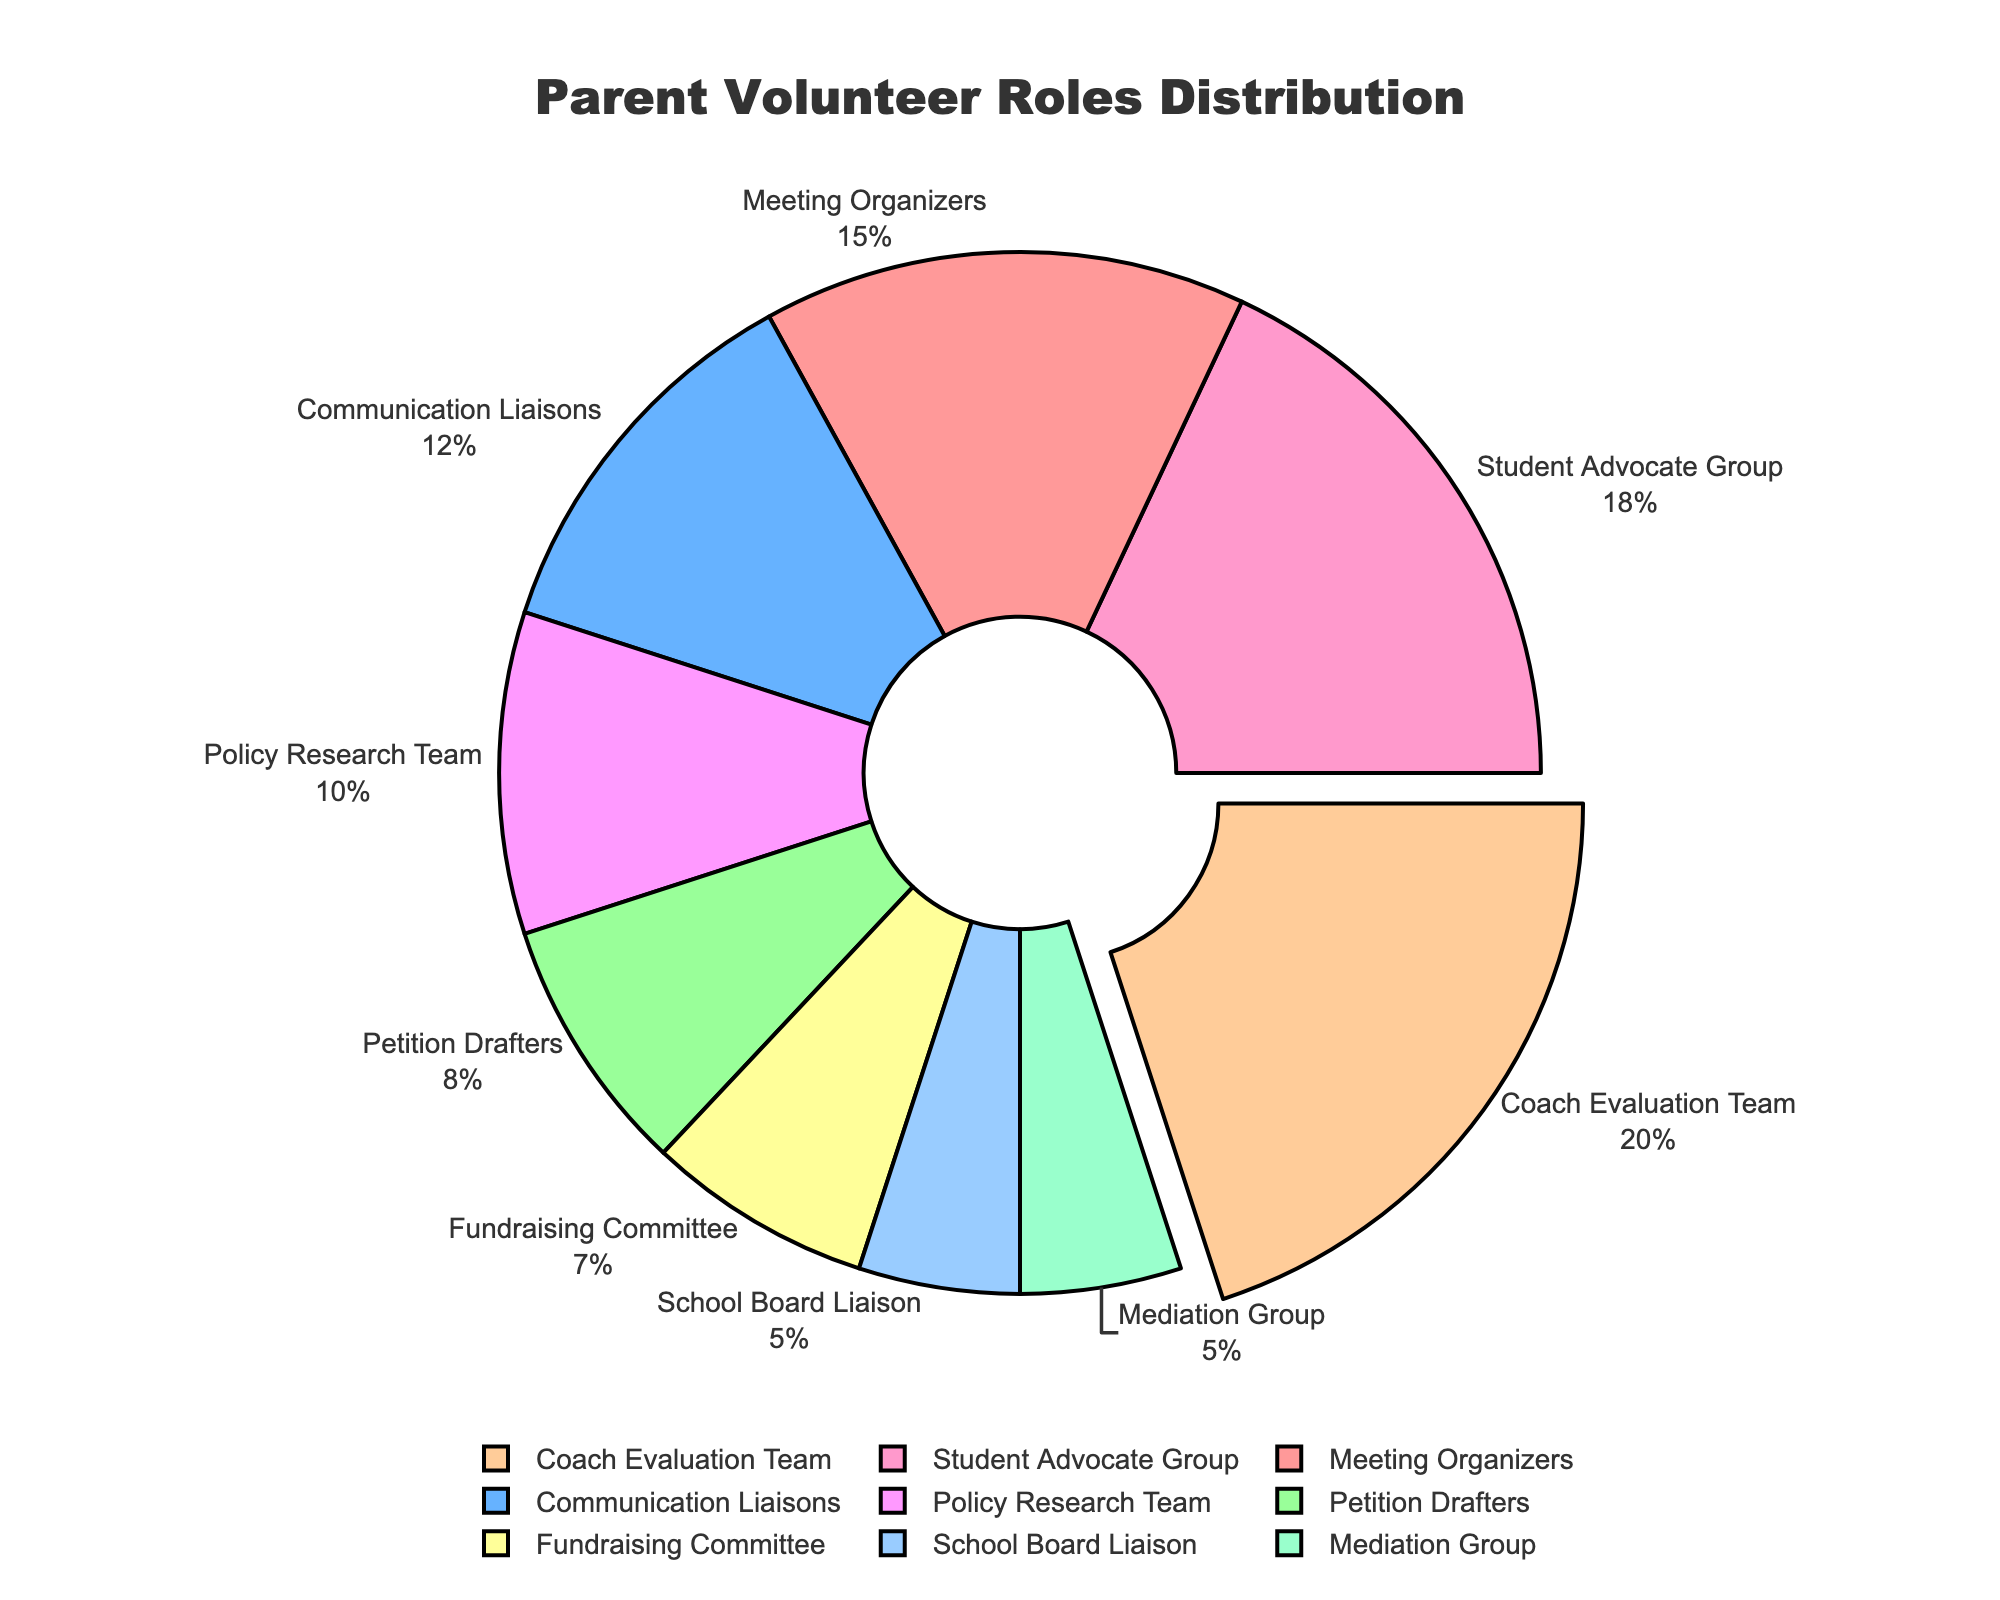What's the largest group of parent volunteers? The largest group is indicated by a slice of the pie chart that is slightly pulled out. This slice corresponds to the "Coach Evaluation Team" with 20% of the total.
Answer: Coach Evaluation Team What's the combined percentage of "Meeting Organizers" and "Communication Liaisons"? Add the percentages of "Meeting Organizers" (15%) and "Communication Liaisons" (12%). The combined percentage is 15% + 12% = 27%.
Answer: 27% Which roles take up less than 10% each on the chart? Observe the slices of the pie chart that represent less than 10% each. These roles are "Petition Drafters" (8%), "School Board Liaison" (5%), "Fundraising Committee" (7%), and "Mediation Group" (5%).
Answer: Petition Drafters, School Board Liaison, Fundraising Committee, Mediation Group How much more percentage does the "Coach Evaluation Team" have compared to the "Communication Liaisons"? Subtract the percentage of "Communication Liaisons" (12%) from the percentage of "Coach Evaluation Team" (20%). The difference is 20% - 12% = 8%.
Answer: 8% Which role is represented by the blue color slice? Identify the slice colored blue. This slice corresponds to "Communication Liaisons" which has a percentage of 12%.
Answer: Communication Liaisons What is the combined percentage of all roles except the highest one? Subtract the percentage of the largest role ("Coach Evaluation Team" with 20%) from 100%. The combined percentage for all other roles is 100% - 20% = 80%.
Answer: 80% What is the difference between the "Student Advocate Group" and the "Policy Research Team"? Subtract the percentage of the "Policy Research Team" (10%) from the "Student Advocate Group" (18%). The difference is 18% - 10% = 8%.
Answer: 8% What's the average percentage of all roles? Sum up the percentages of all roles (15% + 12% + 8% + 20% + 18% + 5% + 7% + 10% + 5% = 100%). Then divide this sum by the number of roles (9). The average percentage is 100% / 9 ≈ 11.11%.
Answer: 11.11% What percentage of parent volunteers are involved in roles directly related to policy or mediation (Policy Research Team and Mediation Group)? Add the percentages of "Policy Research Team" (10%) and "Mediation Group" (5%). The combined percentage is 10% + 5% = 15%.
Answer: 15% 